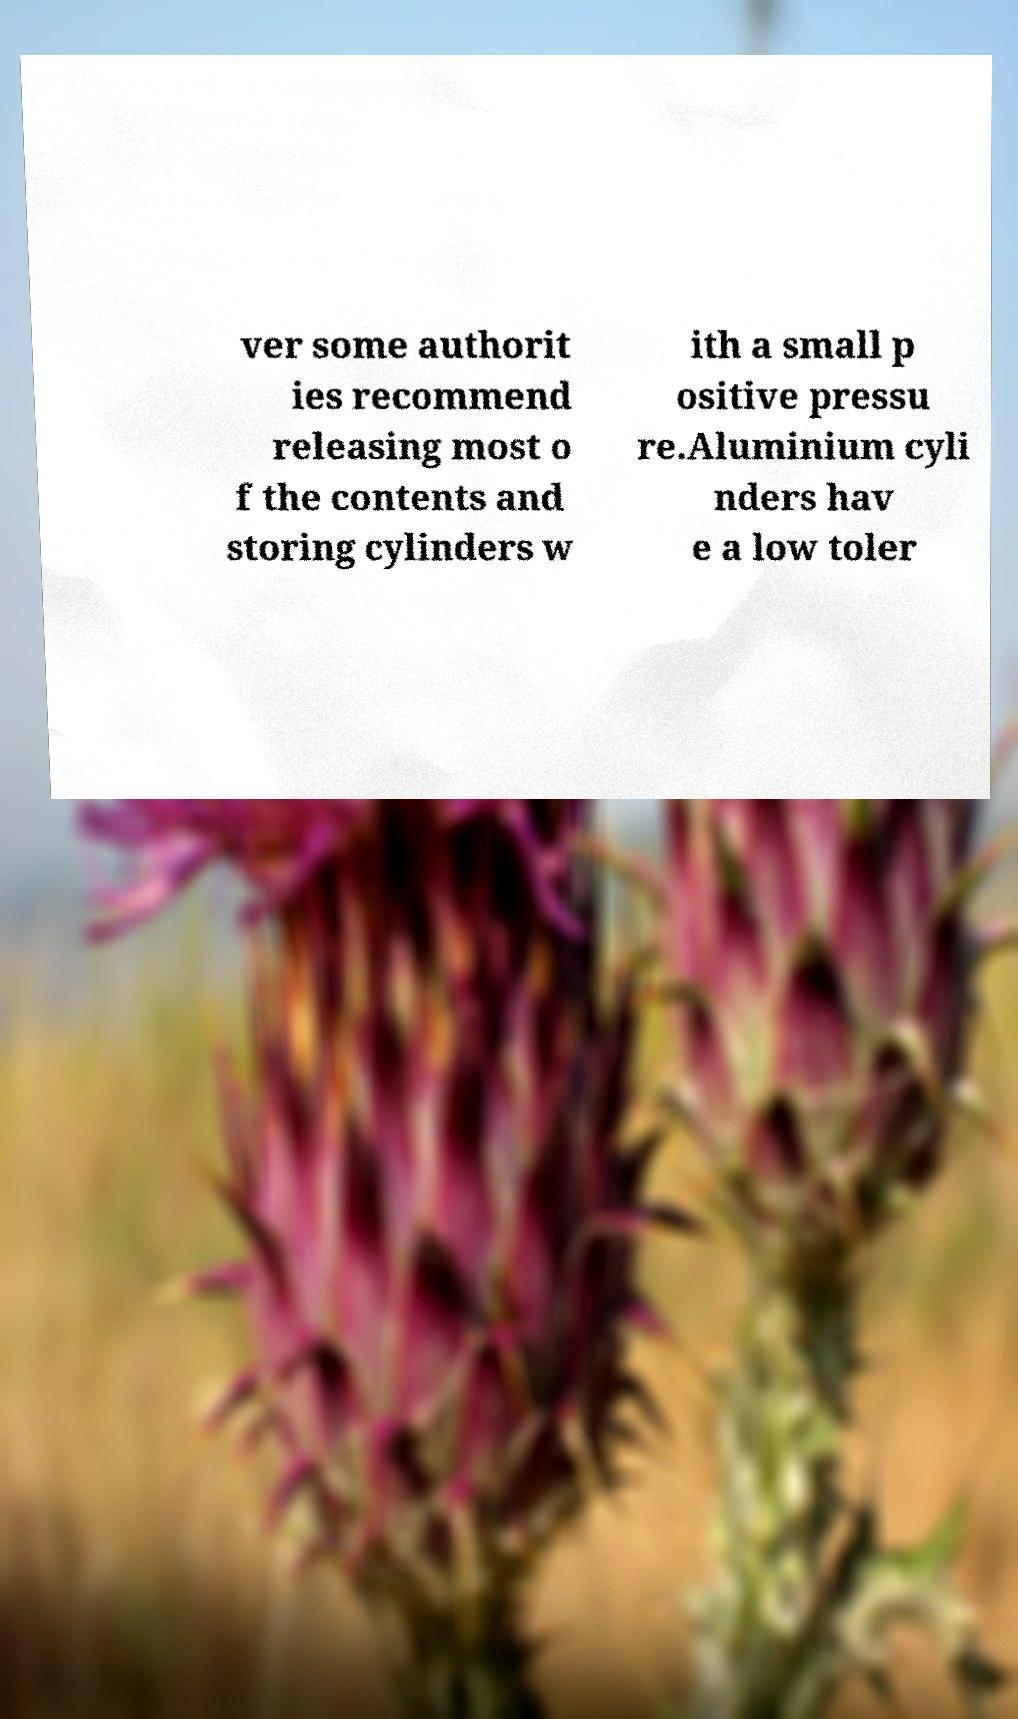I need the written content from this picture converted into text. Can you do that? ver some authorit ies recommend releasing most o f the contents and storing cylinders w ith a small p ositive pressu re.Aluminium cyli nders hav e a low toler 